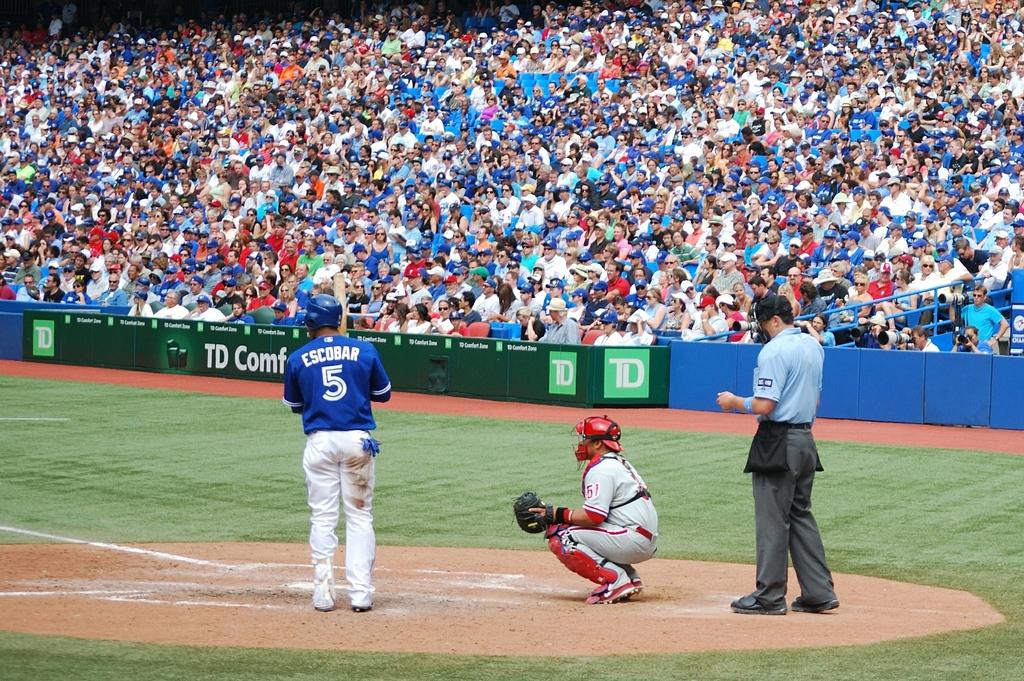What number is the batter?
Offer a terse response. 5. 